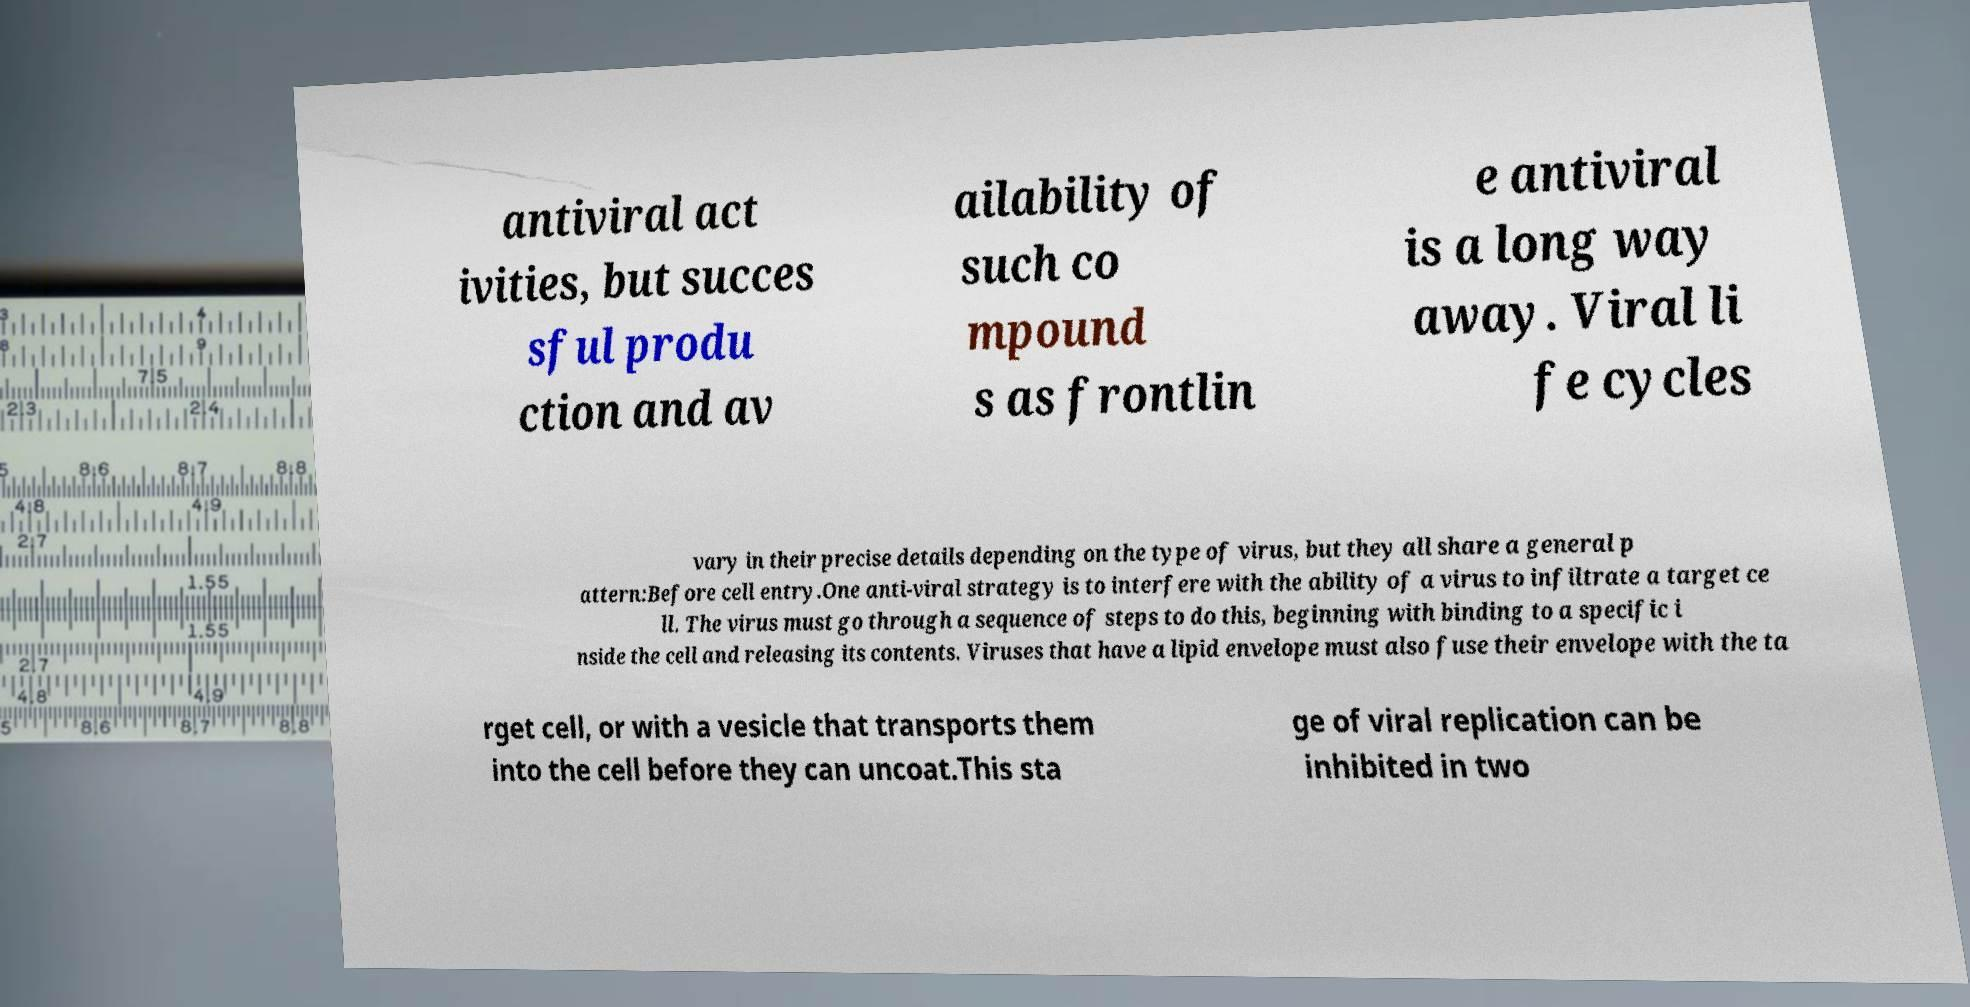What messages or text are displayed in this image? I need them in a readable, typed format. antiviral act ivities, but succes sful produ ction and av ailability of such co mpound s as frontlin e antiviral is a long way away. Viral li fe cycles vary in their precise details depending on the type of virus, but they all share a general p attern:Before cell entry.One anti-viral strategy is to interfere with the ability of a virus to infiltrate a target ce ll. The virus must go through a sequence of steps to do this, beginning with binding to a specific i nside the cell and releasing its contents. Viruses that have a lipid envelope must also fuse their envelope with the ta rget cell, or with a vesicle that transports them into the cell before they can uncoat.This sta ge of viral replication can be inhibited in two 